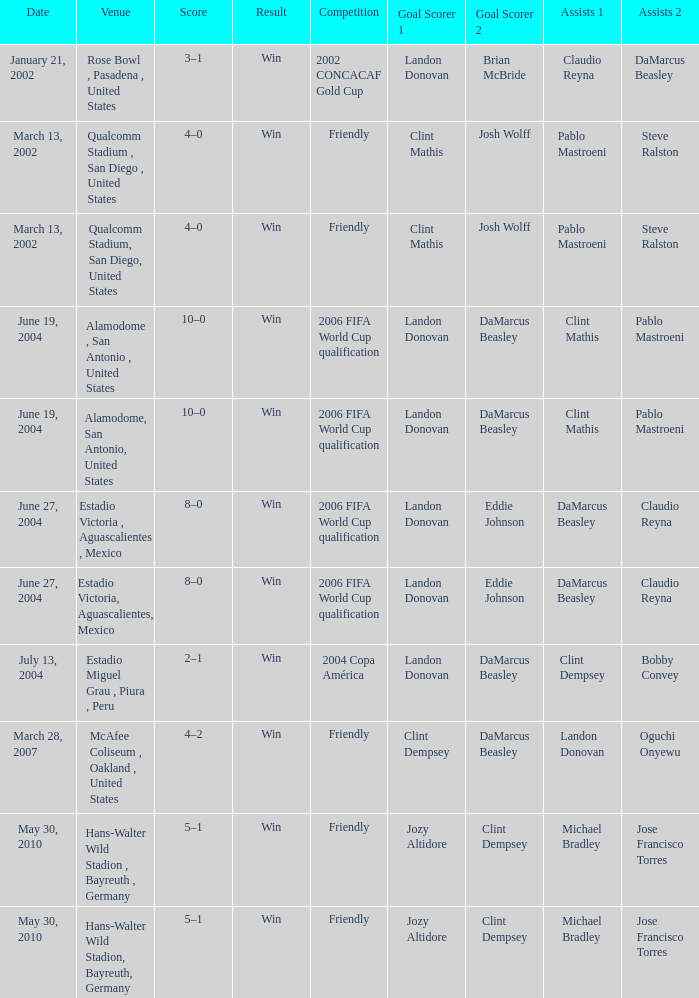What date has 2006 fifa world cup qualification as the competition, and alamodome, san antonio, united States as the venue? June 19, 2004, June 19, 2004. 